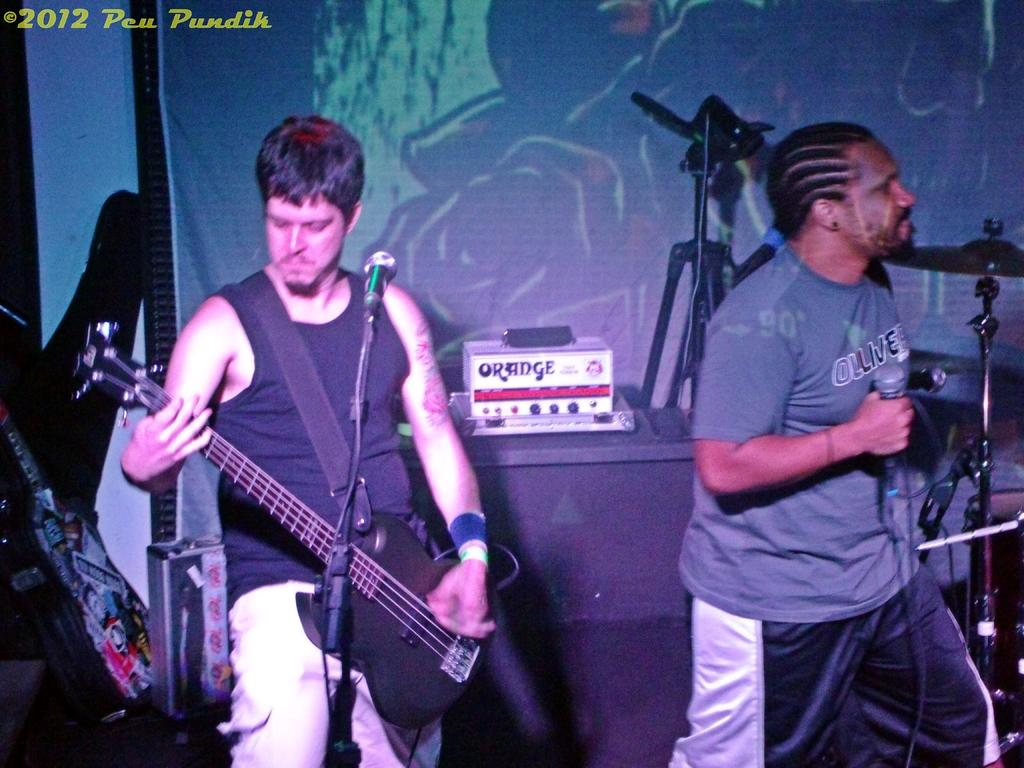What is the man in the image doing? There is a man in the image playing a guitar. Is there anyone else in the image? Yes, there is another man in the image standing by. What is the standing man holding in his hand? The standing man is holding a microphone in his hand. Where is the crib located in the image? There is no crib present in the image. What type of education is being provided in the image? There is no indication of any educational activity in the image. 